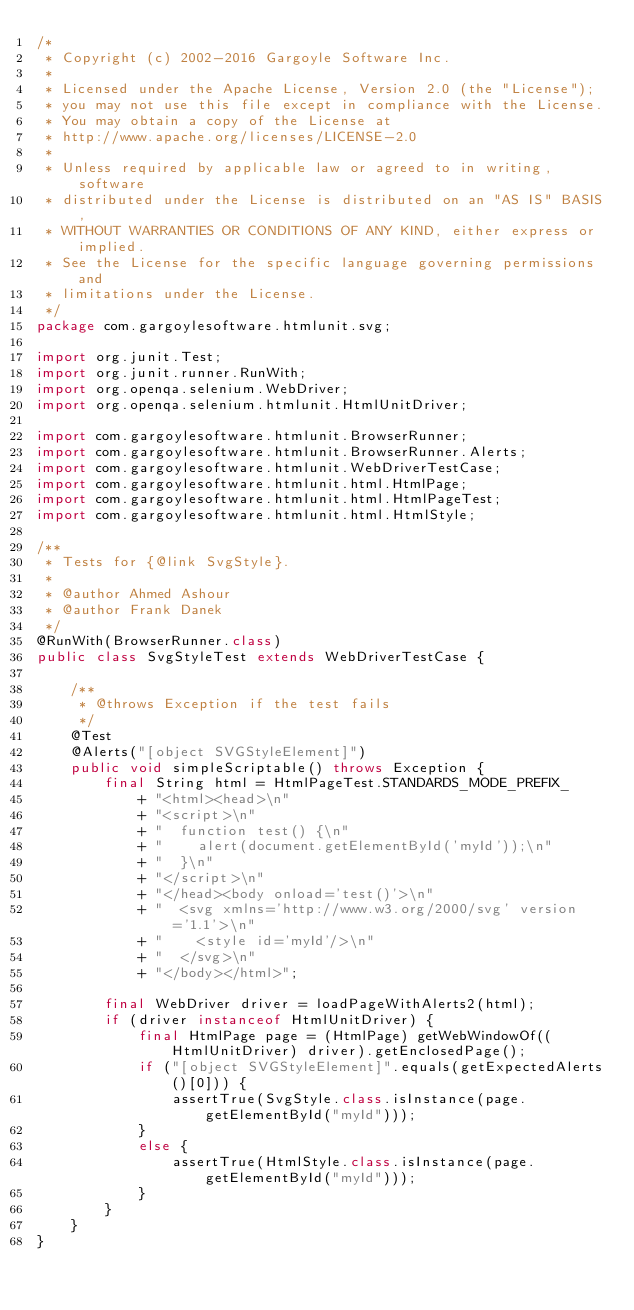<code> <loc_0><loc_0><loc_500><loc_500><_Java_>/*
 * Copyright (c) 2002-2016 Gargoyle Software Inc.
 *
 * Licensed under the Apache License, Version 2.0 (the "License");
 * you may not use this file except in compliance with the License.
 * You may obtain a copy of the License at
 * http://www.apache.org/licenses/LICENSE-2.0
 *
 * Unless required by applicable law or agreed to in writing, software
 * distributed under the License is distributed on an "AS IS" BASIS,
 * WITHOUT WARRANTIES OR CONDITIONS OF ANY KIND, either express or implied.
 * See the License for the specific language governing permissions and
 * limitations under the License.
 */
package com.gargoylesoftware.htmlunit.svg;

import org.junit.Test;
import org.junit.runner.RunWith;
import org.openqa.selenium.WebDriver;
import org.openqa.selenium.htmlunit.HtmlUnitDriver;

import com.gargoylesoftware.htmlunit.BrowserRunner;
import com.gargoylesoftware.htmlunit.BrowserRunner.Alerts;
import com.gargoylesoftware.htmlunit.WebDriverTestCase;
import com.gargoylesoftware.htmlunit.html.HtmlPage;
import com.gargoylesoftware.htmlunit.html.HtmlPageTest;
import com.gargoylesoftware.htmlunit.html.HtmlStyle;

/**
 * Tests for {@link SvgStyle}.
 *
 * @author Ahmed Ashour
 * @author Frank Danek
 */
@RunWith(BrowserRunner.class)
public class SvgStyleTest extends WebDriverTestCase {

    /**
     * @throws Exception if the test fails
     */
    @Test
    @Alerts("[object SVGStyleElement]")
    public void simpleScriptable() throws Exception {
        final String html = HtmlPageTest.STANDARDS_MODE_PREFIX_
            + "<html><head>\n"
            + "<script>\n"
            + "  function test() {\n"
            + "    alert(document.getElementById('myId'));\n"
            + "  }\n"
            + "</script>\n"
            + "</head><body onload='test()'>\n"
            + "  <svg xmlns='http://www.w3.org/2000/svg' version='1.1'>\n"
            + "    <style id='myId'/>\n"
            + "  </svg>\n"
            + "</body></html>";

        final WebDriver driver = loadPageWithAlerts2(html);
        if (driver instanceof HtmlUnitDriver) {
            final HtmlPage page = (HtmlPage) getWebWindowOf((HtmlUnitDriver) driver).getEnclosedPage();
            if ("[object SVGStyleElement]".equals(getExpectedAlerts()[0])) {
                assertTrue(SvgStyle.class.isInstance(page.getElementById("myId")));
            }
            else {
                assertTrue(HtmlStyle.class.isInstance(page.getElementById("myId")));
            }
        }
    }
}
</code> 